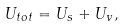<formula> <loc_0><loc_0><loc_500><loc_500>U _ { t o t } = U _ { s } + U _ { v } ,</formula> 